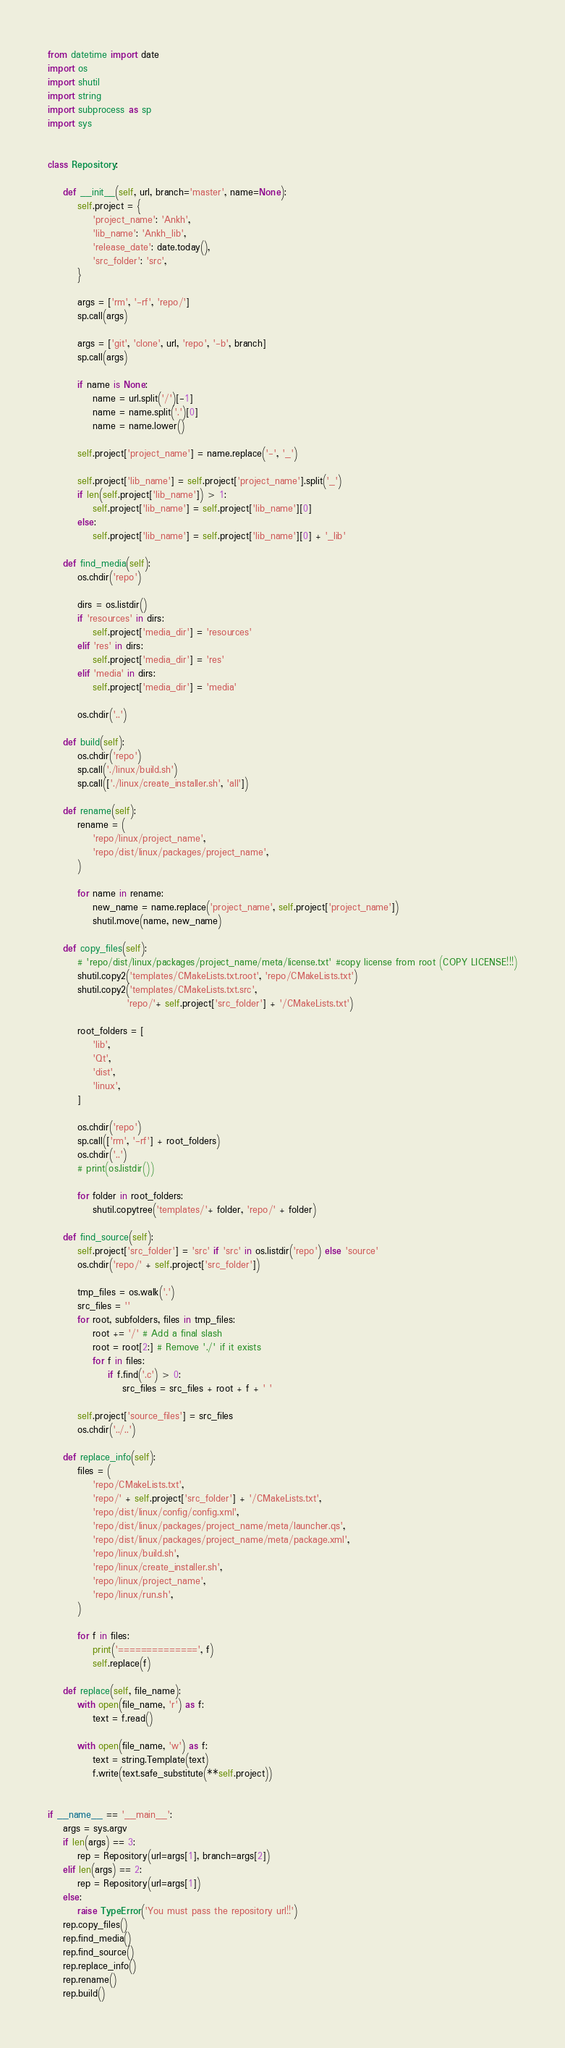Convert code to text. <code><loc_0><loc_0><loc_500><loc_500><_Python_>from datetime import date
import os
import shutil
import string
import subprocess as sp
import sys


class Repository:

    def __init__(self, url, branch='master', name=None):
        self.project = {
            'project_name': 'Ankh',
            'lib_name': 'Ankh_lib',
            'release_date': date.today(),
            'src_folder': 'src',
        }

        args = ['rm', '-rf', 'repo/']
        sp.call(args)

        args = ['git', 'clone', url, 'repo', '-b', branch]
        sp.call(args)

        if name is None:
            name = url.split('/')[-1]
            name = name.split('.')[0]
            name = name.lower()

        self.project['project_name'] = name.replace('-', '_')

        self.project['lib_name'] = self.project['project_name'].split('_')
        if len(self.project['lib_name']) > 1:
            self.project['lib_name'] = self.project['lib_name'][0]
        else:
            self.project['lib_name'] = self.project['lib_name'][0] + '_lib'

    def find_media(self):
        os.chdir('repo')

        dirs = os.listdir()
        if 'resources' in dirs:
            self.project['media_dir'] = 'resources'
        elif 'res' in dirs:
            self.project['media_dir'] = 'res'
        elif 'media' in dirs:
            self.project['media_dir'] = 'media'

        os.chdir('..')

    def build(self):
        os.chdir('repo')
        sp.call('./linux/build.sh')
        sp.call(['./linux/create_installer.sh', 'all'])

    def rename(self):
        rename = (
            'repo/linux/project_name',
            'repo/dist/linux/packages/project_name',
        )

        for name in rename:
            new_name = name.replace('project_name', self.project['project_name'])
            shutil.move(name, new_name)

    def copy_files(self):
        # 'repo/dist/linux/packages/project_name/meta/license.txt' #copy license from root (COPY LICENSE!!!)
        shutil.copy2('templates/CMakeLists.txt.root', 'repo/CMakeLists.txt')
        shutil.copy2('templates/CMakeLists.txt.src',
                     'repo/'+ self.project['src_folder'] + '/CMakeLists.txt')

        root_folders = [
            'lib',
            'Qt',
            'dist',
            'linux',
        ]

        os.chdir('repo')
        sp.call(['rm', '-rf'] + root_folders)
        os.chdir('..')
        # print(os.listdir())

        for folder in root_folders:
            shutil.copytree('templates/'+ folder, 'repo/' + folder)

    def find_source(self):
        self.project['src_folder'] = 'src' if 'src' in os.listdir('repo') else 'source'
        os.chdir('repo/' + self.project['src_folder'])

        tmp_files = os.walk('.')
        src_files = ''
        for root, subfolders, files in tmp_files:
            root += '/' # Add a final slash
            root = root[2:] # Remove './' if it exists
            for f in files:
                if f.find('.c') > 0:
                    src_files = src_files + root + f + ' '

        self.project['source_files'] = src_files
        os.chdir('../..')

    def replace_info(self):
        files = (
            'repo/CMakeLists.txt',
            'repo/' + self.project['src_folder'] + '/CMakeLists.txt',
            'repo/dist/linux/config/config.xml',
            'repo/dist/linux/packages/project_name/meta/launcher.qs',
            'repo/dist/linux/packages/project_name/meta/package.xml',
            'repo/linux/build.sh',
            'repo/linux/create_installer.sh',
            'repo/linux/project_name',
            'repo/linux/run.sh',
        )

        for f in files:
            print('==============', f)
            self.replace(f)

    def replace(self, file_name):
        with open(file_name, 'r') as f:
            text = f.read()

        with open(file_name, 'w') as f:
            text = string.Template(text)
            f.write(text.safe_substitute(**self.project))


if __name__ == '__main__':
    args = sys.argv
    if len(args) == 3:
        rep = Repository(url=args[1], branch=args[2])
    elif len(args) == 2:
        rep = Repository(url=args[1])
    else:
        raise TypeError('You must pass the repository url!!')
    rep.copy_files()
    rep.find_media()
    rep.find_source()
    rep.replace_info()
    rep.rename()
    rep.build()
</code> 